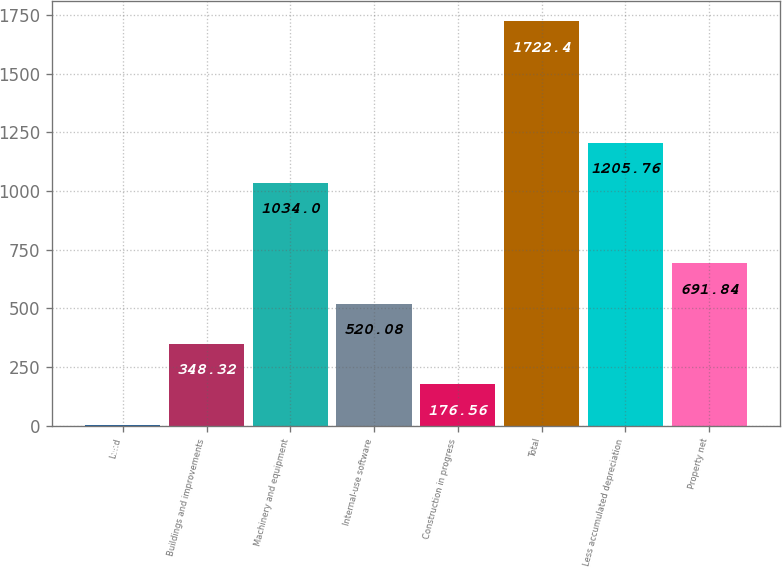Convert chart to OTSL. <chart><loc_0><loc_0><loc_500><loc_500><bar_chart><fcel>Land<fcel>Buildings and improvements<fcel>Machinery and equipment<fcel>Internal-use software<fcel>Construction in progress<fcel>Total<fcel>Less accumulated depreciation<fcel>Property net<nl><fcel>4.8<fcel>348.32<fcel>1034<fcel>520.08<fcel>176.56<fcel>1722.4<fcel>1205.76<fcel>691.84<nl></chart> 